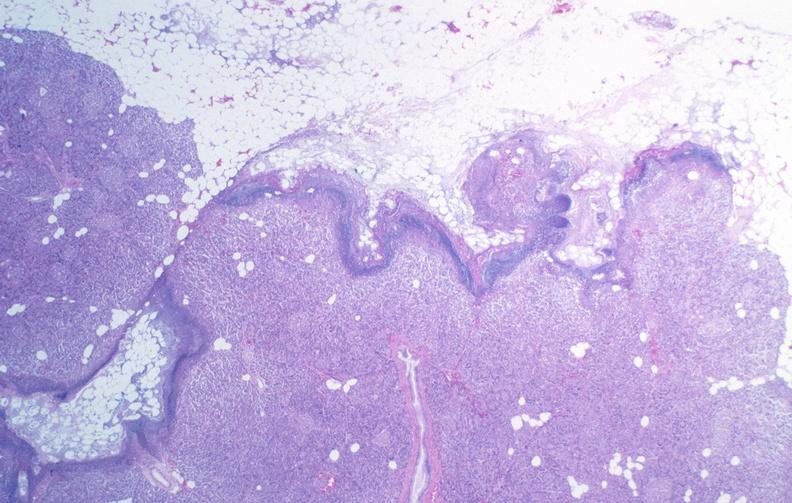where is this?
Answer the question using a single word or phrase. Pancreas 